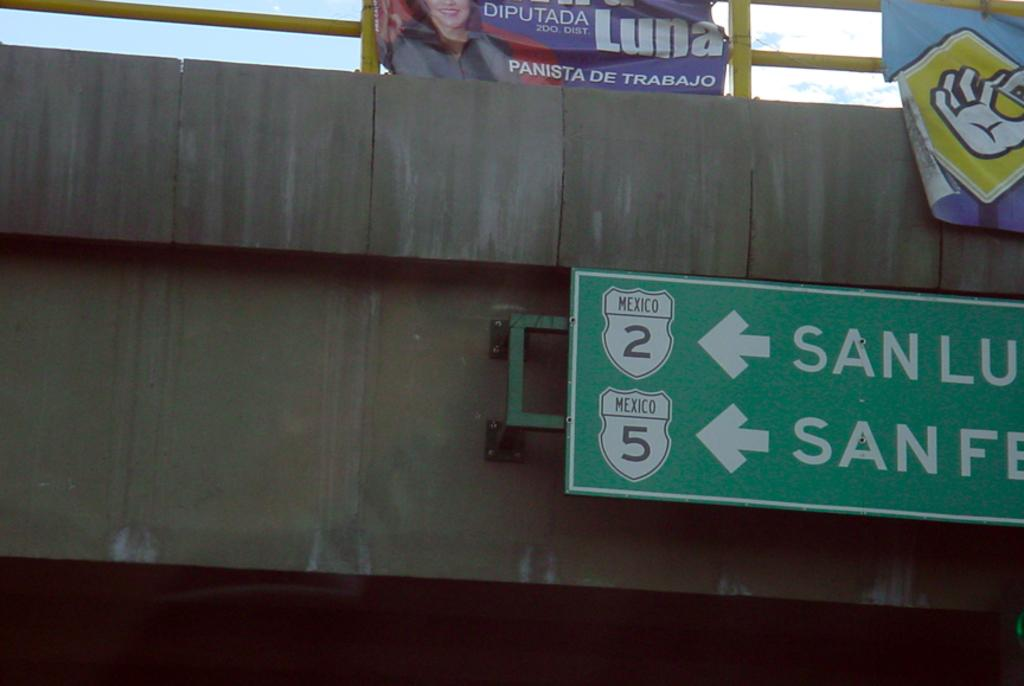<image>
Relay a brief, clear account of the picture shown. Street sign saying San Lu is on the left. 